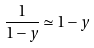<formula> <loc_0><loc_0><loc_500><loc_500>\frac { 1 } { 1 - y } \simeq 1 - y</formula> 